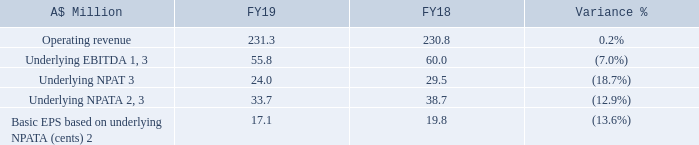Financials
1. EBITDA is a non-IFRS term, defined as earnings before interest, tax, depreciation and amortisation, and excluding net foreign exchange gains (losses).
2. NPATA is a non-IFRS term, defined as net profit after tax, excluding tax-effected amortisation of acquired intangibles. This is used to determine EPSa as disclosed here and in the audited Remuneration Report.
3. Underlying EBITDA, underlying NPAT and underlying NPATA exclude separately disclosed items, which represent the transaction and other restructuring costs associated with the Sigma acquisition (2018: Enoro acquisition) and the exiting of a premises lease in the Americas. Further details of the separately disclosed items are outlined in Note 4 to the Financial Report.
Operating revenue for FY19 was $231.3 million, $0.5 million up on FY18. With Sigma contributing $5.0 million of revenue in June (the first month since acquisition), revenues for the remainder of Hansen excluding Sigma were $4.5 million lower. This decline was a result of lower non-recurring revenues, due primarily to both lower one-off licence fees and reduced project work following the large body of work completed in the first half of FY18 associated with implementing Power of Choice in Australia. Conversely, recurring revenues grew to represent 63% of total operating revenue.
Underlying EBITDA for the year was $55.8 million, 7.0% down on the $60.0 million in FY18. This resulted in an underlying EBITDA margin decline to 24.1% from 26.0% in FY18. Sigma only contributed a modest $0.1 million of EBITDA in June, which we do not see as representative of the business going forward. Excluding Sigma, the underlying EBITDA margin was 24.6%. This reduced margin was the direct result of the lower non-recurring revenue, as we were able to maintain operating expenses at the same level as FY18, even after the investment in the Vietnam Development Centre.
What was the operating revenue for 2019? $231.3 million. Why did the operating revenue increase? With sigma contributing $5.0 million of revenue in june (the first month since acquisition), revenues for the remainder of hansen excluding sigma were $4.5 million lower. this decline was a result of lower non-recurring revenues, due primarily to both lower one-off licence fees and reduced project work following the large body of work completed in the first half of fy18 associated with implementing power of choice in australia. What was the underlying EBITDA for 2019?
Answer scale should be: million. 55.8. What was the average operating revenue for the two FYs?
Answer scale should be: million. (231.3 + 230.8)/2 
Answer: 231.05. What was the difference between EBITDA and NPAT for FY18?
Answer scale should be: million. 60.0 - 29.5 
Answer: 30.5. What was the average basic EPS for the 2 FYs? (17.1 + 19.8)/2 
Answer: 18.45. 